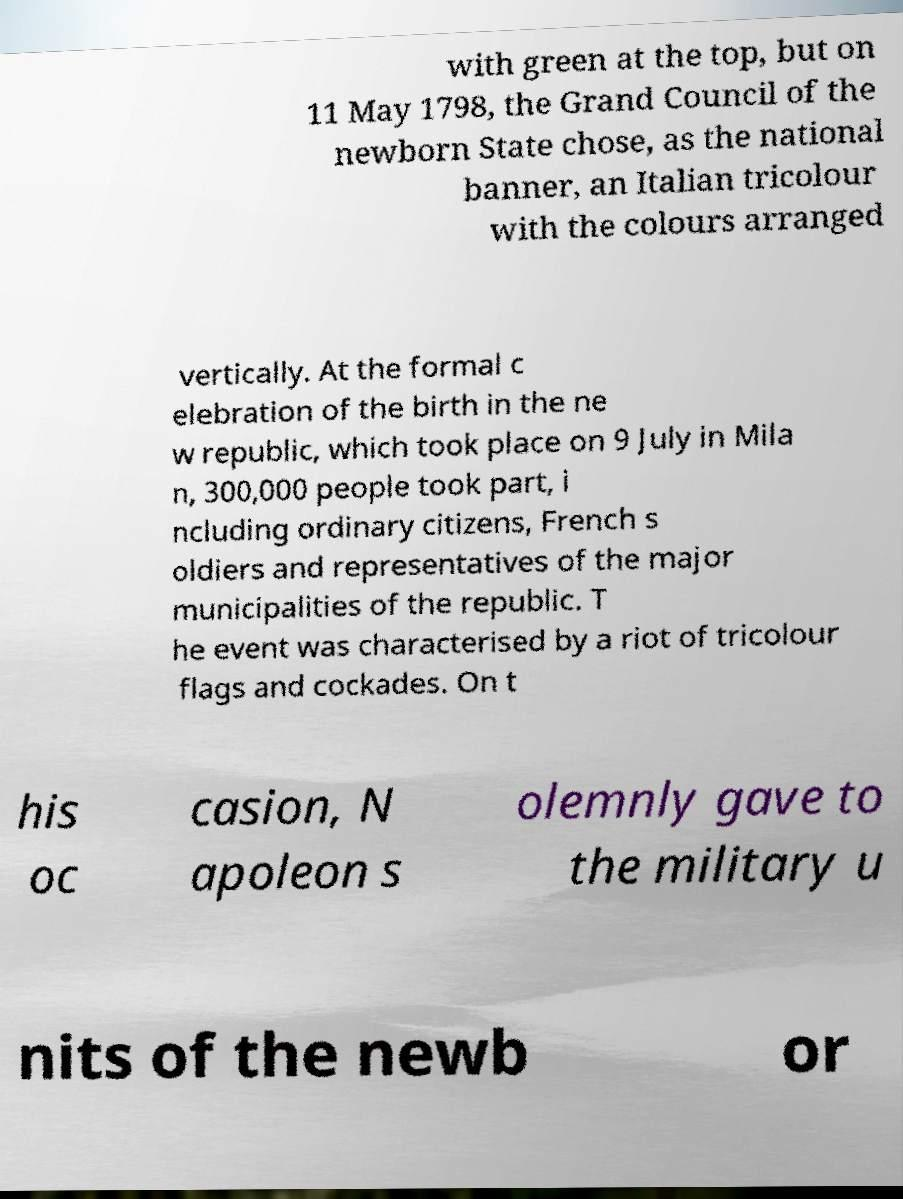Please identify and transcribe the text found in this image. with green at the top, but on 11 May 1798, the Grand Council of the newborn State chose, as the national banner, an Italian tricolour with the colours arranged vertically. At the formal c elebration of the birth in the ne w republic, which took place on 9 July in Mila n, 300,000 people took part, i ncluding ordinary citizens, French s oldiers and representatives of the major municipalities of the republic. T he event was characterised by a riot of tricolour flags and cockades. On t his oc casion, N apoleon s olemnly gave to the military u nits of the newb or 